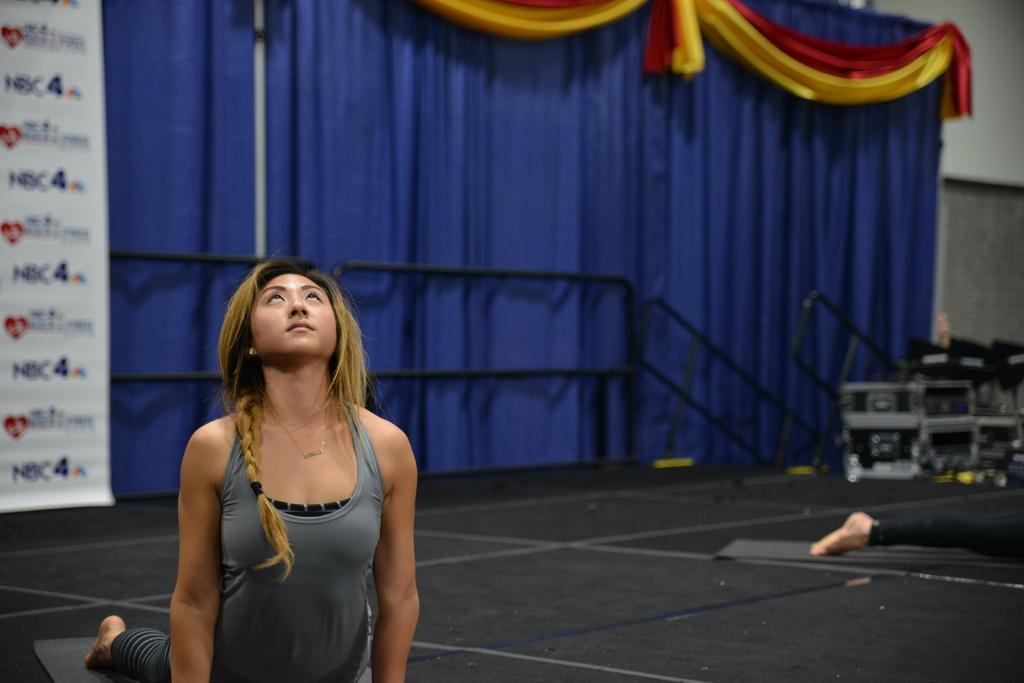Describe this image in one or two sentences. In this picture I see a woman in front who is on the floor and I see another person on the right side of this image and in the background I see the curtains and I see the railing in front of the curtains and on the left side of this image I see a board on which something is written. 